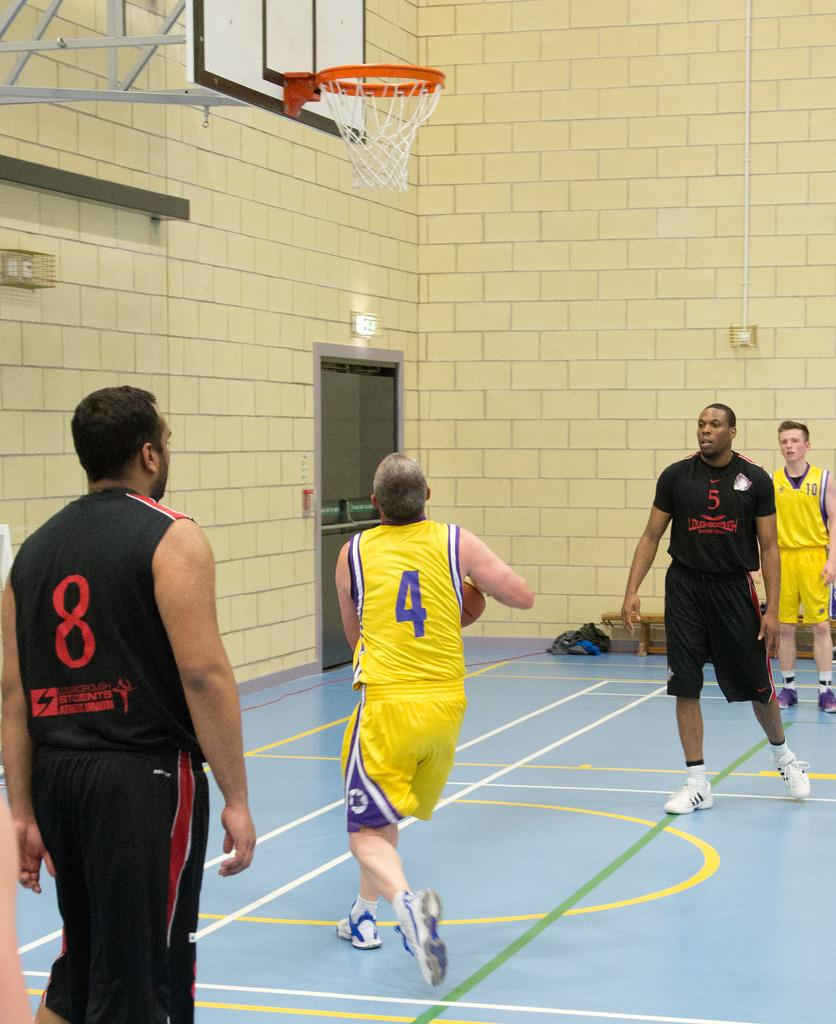<image>
Give a short and clear explanation of the subsequent image. Two players in black tops with Students Athletic Union on them watch a yellow shirted player shoot for the hoop. 